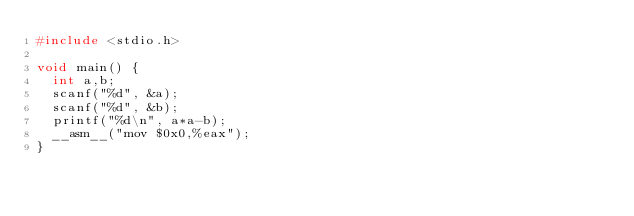<code> <loc_0><loc_0><loc_500><loc_500><_C_>#include <stdio.h>
 
void main() {
  int a,b;
  scanf("%d", &a);
  scanf("%d", &b);
  printf("%d\n", a*a-b);
  __asm__("mov $0x0,%eax");
}</code> 